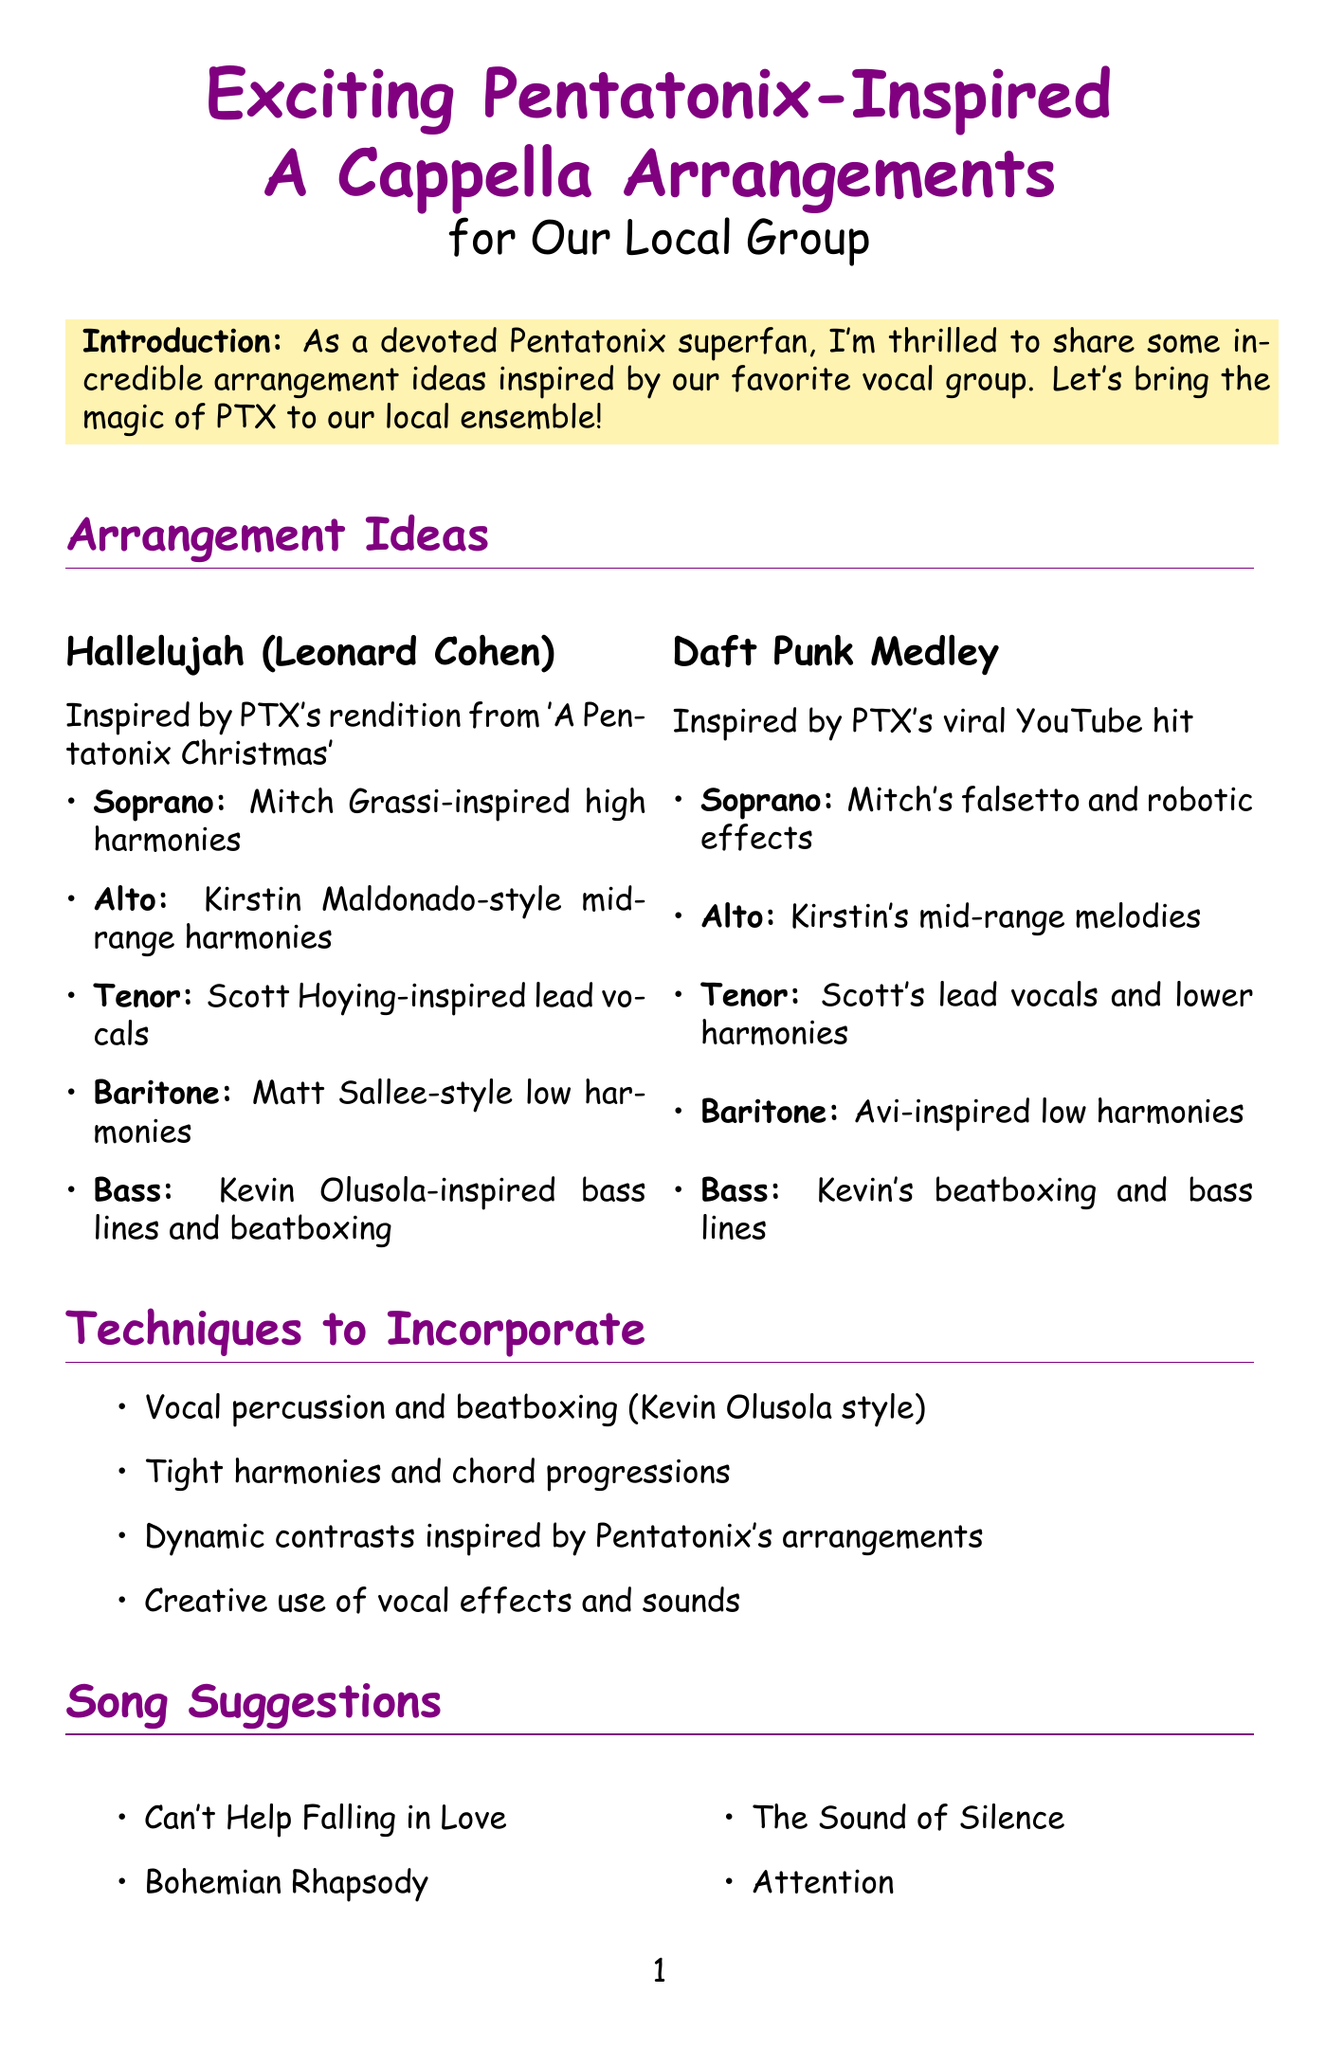What is the title of the memo? The title of the memo is stated at the beginning of the document.
Answer: Exciting Pentatonix-Inspired A Cappella Arrangements for Our Local Group Who is the original artist of "Hallelujah"? The original artist of "Hallelujah" is mentioned in the arrangement section.
Answer: Leonard Cohen What style of harmonies is assigned to the bass part in "Hallelujah"? The assigned style of harmonies for the bass part is explicitly stated in the part assignments for "Hallelujah."
Answer: Kevin Olusola-inspired low bass lines and beatboxing Which song is suggested along with "Bohemian Rhapsody"? The document provides a list of song suggestions, where one of them appears next to "Bohemian Rhapsody."
Answer: Can't Help Falling in Love What technique involves "Kevin Olusola style"? The techniques to be incorporated include specific references that mention vocal styles, including one attributed to Kevin Olusola.
Answer: Vocal percussion and beatboxing How many songs are suggested in total? The total number of songs suggested can be calculated based on the list provided in the document.
Answer: Four Which arrangement is inspired by a viral YouTube hit? The type of inspiration for each arrangement is clearly stated in the document.
Answer: Daft Punk Medley What should be focused on to achieve the signature PTX sound? The document mentions specific rehearsal tips for achieving a particular sound associated with Pentatonix.
Answer: Blend and balance 